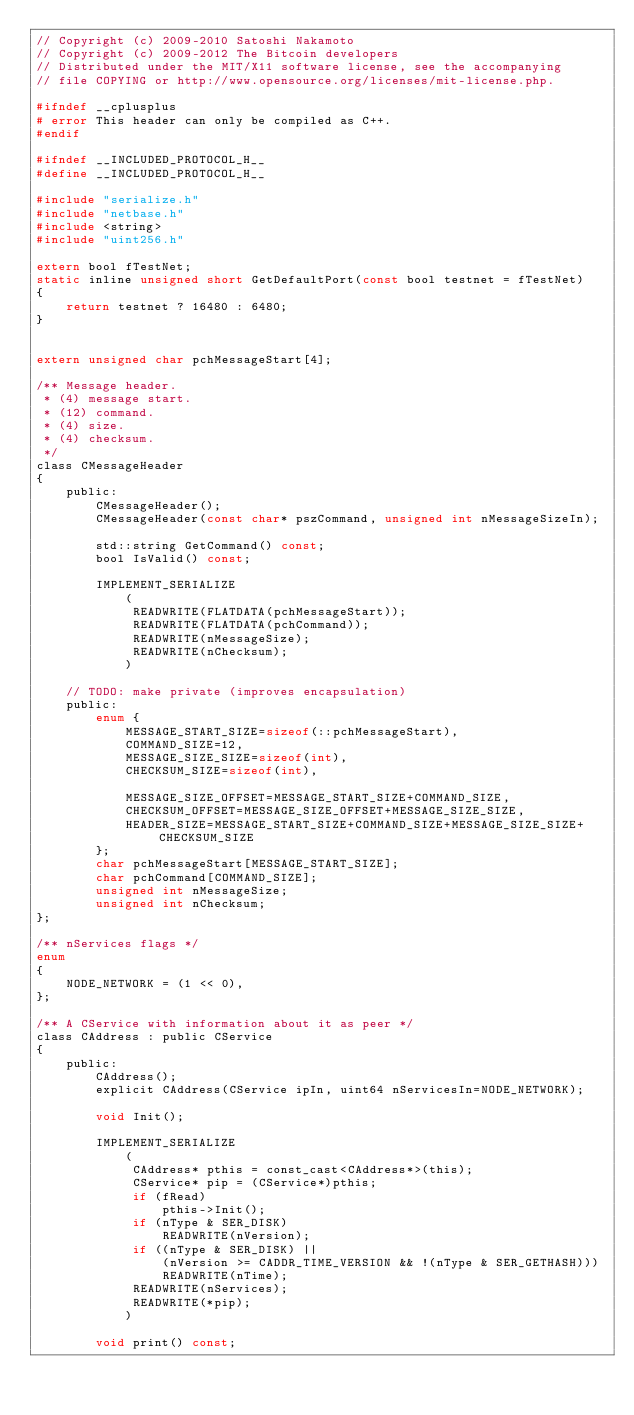<code> <loc_0><loc_0><loc_500><loc_500><_C_>// Copyright (c) 2009-2010 Satoshi Nakamoto
// Copyright (c) 2009-2012 The Bitcoin developers
// Distributed under the MIT/X11 software license, see the accompanying
// file COPYING or http://www.opensource.org/licenses/mit-license.php.

#ifndef __cplusplus
# error This header can only be compiled as C++.
#endif

#ifndef __INCLUDED_PROTOCOL_H__
#define __INCLUDED_PROTOCOL_H__

#include "serialize.h"
#include "netbase.h"
#include <string>
#include "uint256.h"

extern bool fTestNet;
static inline unsigned short GetDefaultPort(const bool testnet = fTestNet)
{
    return testnet ? 16480 : 6480;
}


extern unsigned char pchMessageStart[4];

/** Message header.
 * (4) message start.
 * (12) command.
 * (4) size.
 * (4) checksum.
 */
class CMessageHeader
{
    public:
        CMessageHeader();
        CMessageHeader(const char* pszCommand, unsigned int nMessageSizeIn);

        std::string GetCommand() const;
        bool IsValid() const;

        IMPLEMENT_SERIALIZE
            (
             READWRITE(FLATDATA(pchMessageStart));
             READWRITE(FLATDATA(pchCommand));
             READWRITE(nMessageSize);
             READWRITE(nChecksum);
            )

    // TODO: make private (improves encapsulation)
    public:
        enum {
            MESSAGE_START_SIZE=sizeof(::pchMessageStart),
            COMMAND_SIZE=12,
            MESSAGE_SIZE_SIZE=sizeof(int),
            CHECKSUM_SIZE=sizeof(int),

            MESSAGE_SIZE_OFFSET=MESSAGE_START_SIZE+COMMAND_SIZE,
            CHECKSUM_OFFSET=MESSAGE_SIZE_OFFSET+MESSAGE_SIZE_SIZE,
            HEADER_SIZE=MESSAGE_START_SIZE+COMMAND_SIZE+MESSAGE_SIZE_SIZE+CHECKSUM_SIZE
        };
        char pchMessageStart[MESSAGE_START_SIZE];
        char pchCommand[COMMAND_SIZE];
        unsigned int nMessageSize;
        unsigned int nChecksum;
};

/** nServices flags */
enum
{
    NODE_NETWORK = (1 << 0),
};

/** A CService with information about it as peer */
class CAddress : public CService
{
    public:
        CAddress();
        explicit CAddress(CService ipIn, uint64 nServicesIn=NODE_NETWORK);

        void Init();

        IMPLEMENT_SERIALIZE
            (
             CAddress* pthis = const_cast<CAddress*>(this);
             CService* pip = (CService*)pthis;
             if (fRead)
                 pthis->Init();
             if (nType & SER_DISK)
                 READWRITE(nVersion);
             if ((nType & SER_DISK) ||
                 (nVersion >= CADDR_TIME_VERSION && !(nType & SER_GETHASH)))
                 READWRITE(nTime);
             READWRITE(nServices);
             READWRITE(*pip);
            )

        void print() const;
</code> 